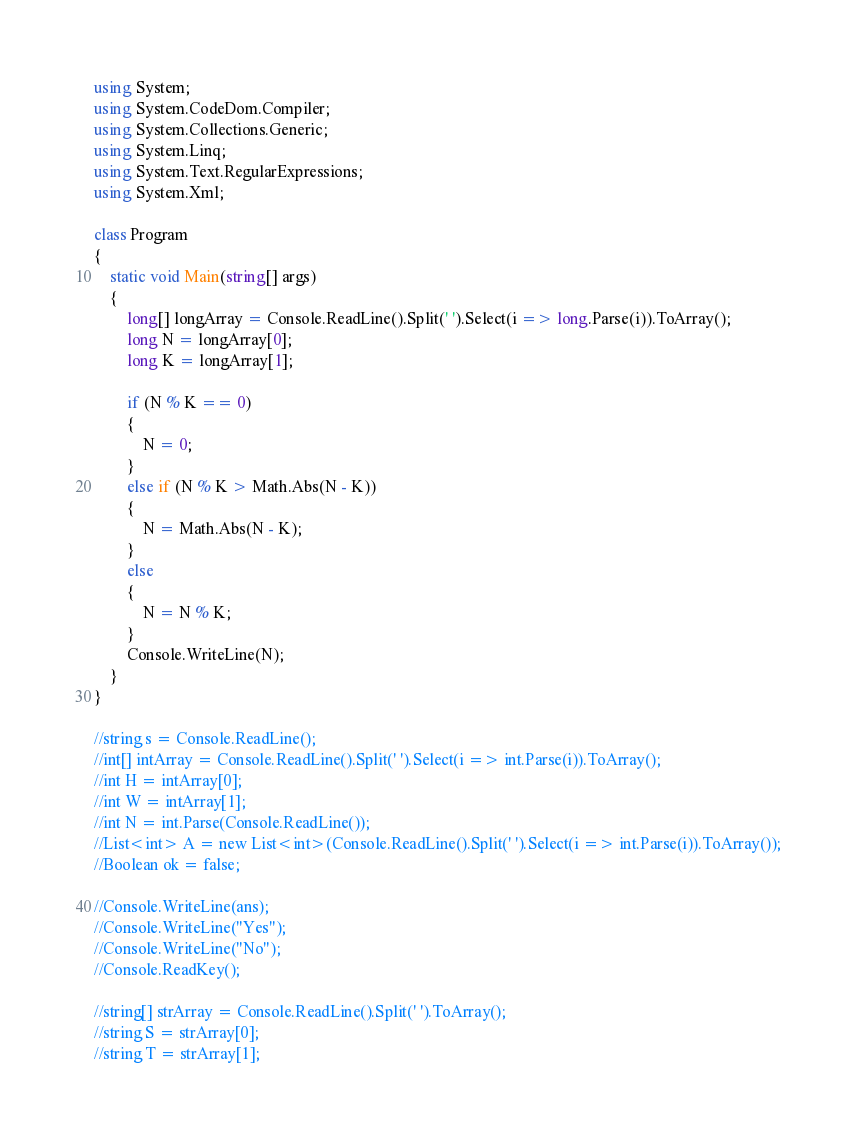<code> <loc_0><loc_0><loc_500><loc_500><_C#_>using System;
using System.CodeDom.Compiler;
using System.Collections.Generic;
using System.Linq;
using System.Text.RegularExpressions;
using System.Xml;

class Program
{
	static void Main(string[] args)
	{
		long[] longArray = Console.ReadLine().Split(' ').Select(i => long.Parse(i)).ToArray();
		long N = longArray[0];
		long K = longArray[1];

		if (N % K == 0)
		{
			N = 0;
		}
		else if (N % K > Math.Abs(N - K))
		{
			N = Math.Abs(N - K);
		}
		else
		{
			N = N % K;
		}
		Console.WriteLine(N);
	}
}

//string s = Console.ReadLine();
//int[] intArray = Console.ReadLine().Split(' ').Select(i => int.Parse(i)).ToArray();
//int H = intArray[0];
//int W = intArray[1];
//int N = int.Parse(Console.ReadLine());
//List<int> A = new List<int>(Console.ReadLine().Split(' ').Select(i => int.Parse(i)).ToArray());
//Boolean ok = false;

//Console.WriteLine(ans);
//Console.WriteLine("Yes");
//Console.WriteLine("No");
//Console.ReadKey();

//string[] strArray = Console.ReadLine().Split(' ').ToArray();
//string S = strArray[0];
//string T = strArray[1];
</code> 